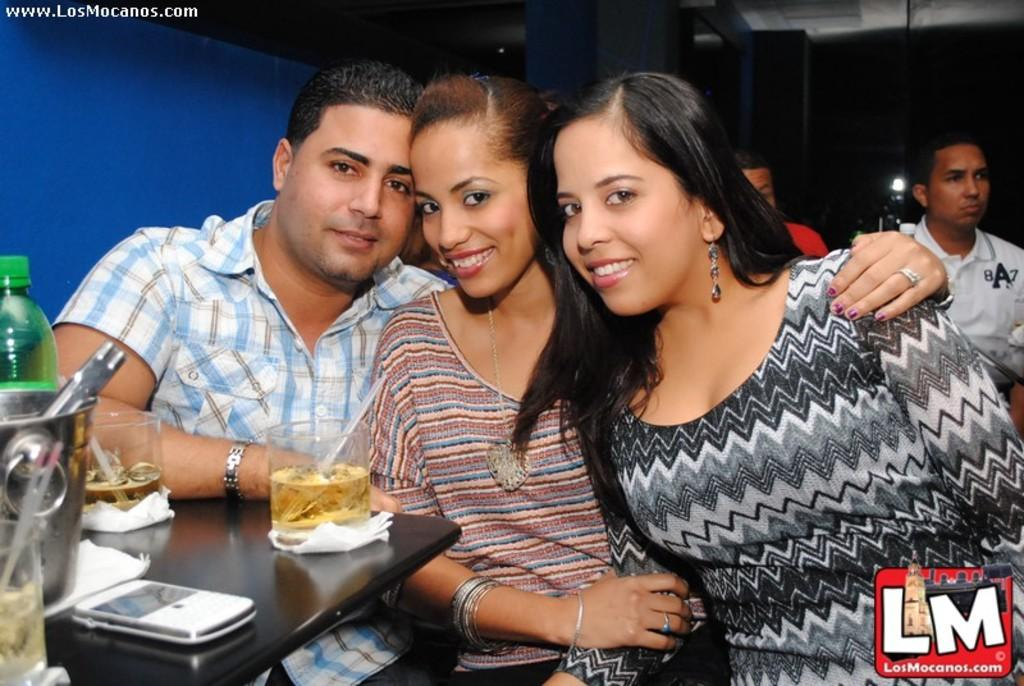How many people are in the image? There are three persons in the image. What is in front of the three persons? There is a table in front of them. What can be seen on the table? There are glasses of wine and a mobile phone on the table. Are there any other objects on the table? Yes, there are other objects on the table. Can you describe the people behind the three persons? There are two persons behind the three persons. What type of pipe is being used by the persons in the image? There is no pipe present in the image. How does the feast smell in the image? There is no feast present in the image, so it is not possible to determine how it might smell. 